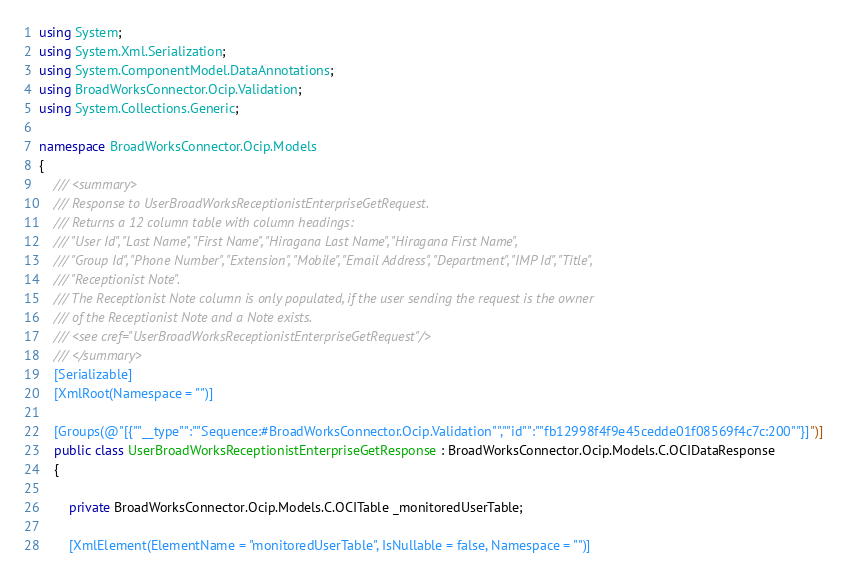Convert code to text. <code><loc_0><loc_0><loc_500><loc_500><_C#_>using System;
using System.Xml.Serialization;
using System.ComponentModel.DataAnnotations;
using BroadWorksConnector.Ocip.Validation;
using System.Collections.Generic;

namespace BroadWorksConnector.Ocip.Models
{
    /// <summary>
    /// Response to UserBroadWorksReceptionistEnterpriseGetRequest.
    /// Returns a 12 column table with column headings:
    /// "User Id", "Last Name", "First Name", "Hiragana Last Name", "Hiragana First Name",
    /// "Group Id", "Phone Number", "Extension", "Mobile", "Email Address", "Department", "IMP Id", "Title",
    /// "Receptionist Note".
    /// The Receptionist Note column is only populated, if the user sending the request is the owner
    /// of the Receptionist Note and a Note exists.
    /// <see cref="UserBroadWorksReceptionistEnterpriseGetRequest"/>
    /// </summary>
    [Serializable]
    [XmlRoot(Namespace = "")]

    [Groups(@"[{""__type"":""Sequence:#BroadWorksConnector.Ocip.Validation"",""id"":""fb12998f4f9e45cedde01f08569f4c7c:200""}]")]
    public class UserBroadWorksReceptionistEnterpriseGetResponse : BroadWorksConnector.Ocip.Models.C.OCIDataResponse
    {

        private BroadWorksConnector.Ocip.Models.C.OCITable _monitoredUserTable;

        [XmlElement(ElementName = "monitoredUserTable", IsNullable = false, Namespace = "")]</code> 